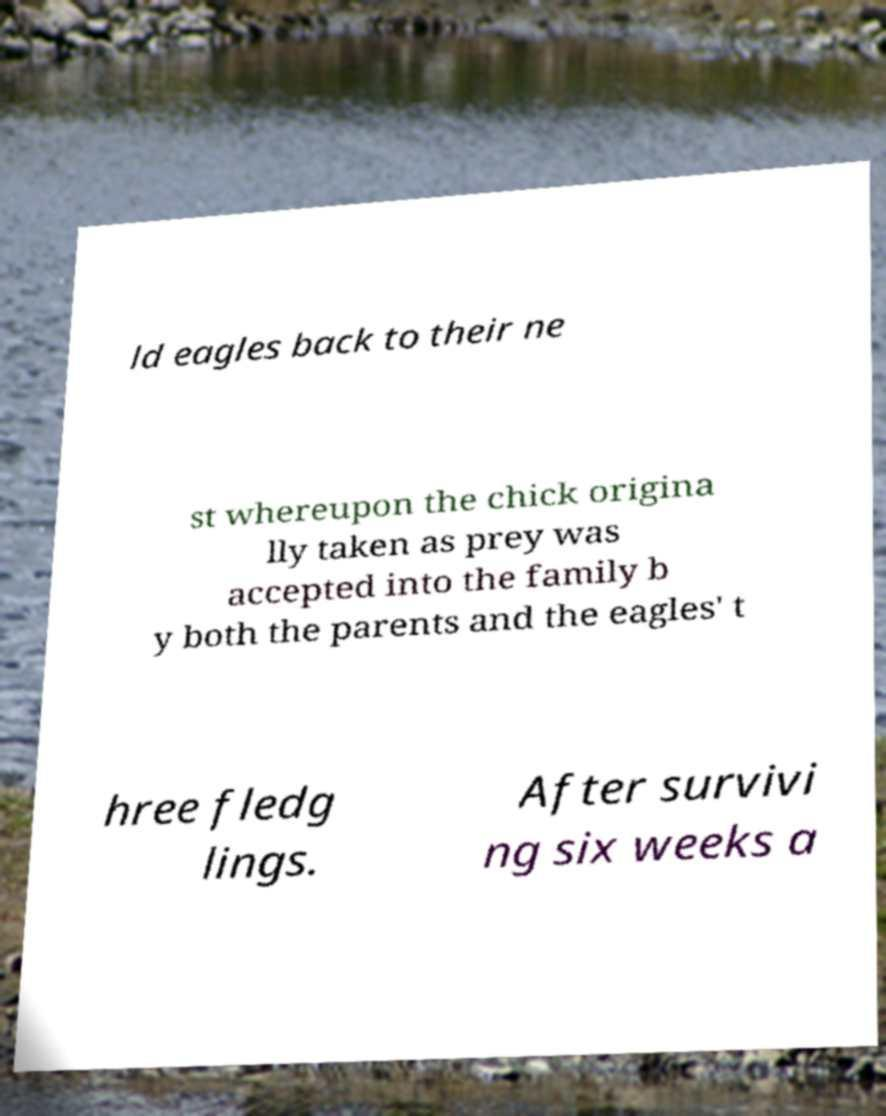Can you read and provide the text displayed in the image?This photo seems to have some interesting text. Can you extract and type it out for me? ld eagles back to their ne st whereupon the chick origina lly taken as prey was accepted into the family b y both the parents and the eagles' t hree fledg lings. After survivi ng six weeks a 